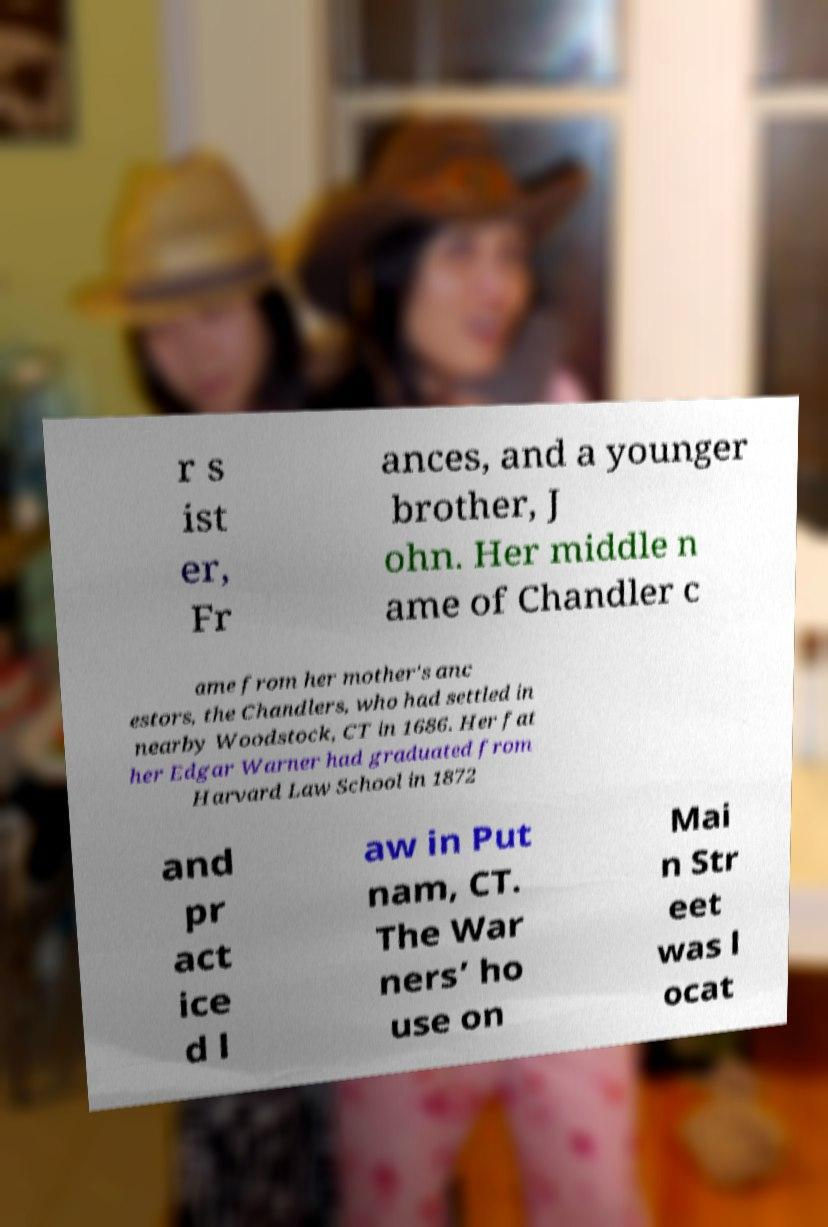Could you assist in decoding the text presented in this image and type it out clearly? r s ist er, Fr ances, and a younger brother, J ohn. Her middle n ame of Chandler c ame from her mother's anc estors, the Chandlers, who had settled in nearby Woodstock, CT in 1686. Her fat her Edgar Warner had graduated from Harvard Law School in 1872 and pr act ice d l aw in Put nam, CT. The War ners’ ho use on Mai n Str eet was l ocat 